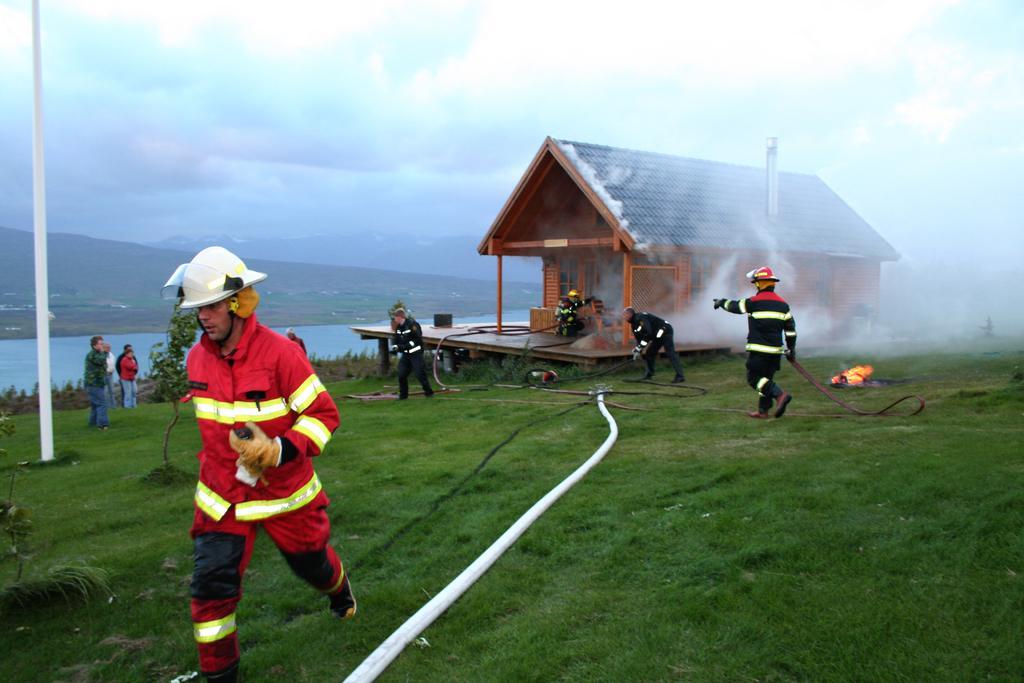Can you describe this image briefly? In the center of the image we can see house, smoke, fire, pipes, some persons, plants, pole are there. In the background of the image hills are there. At the top of the image clouds are present in the sky. At the bottom of the image ground is there. In the middle of the image water is there. 